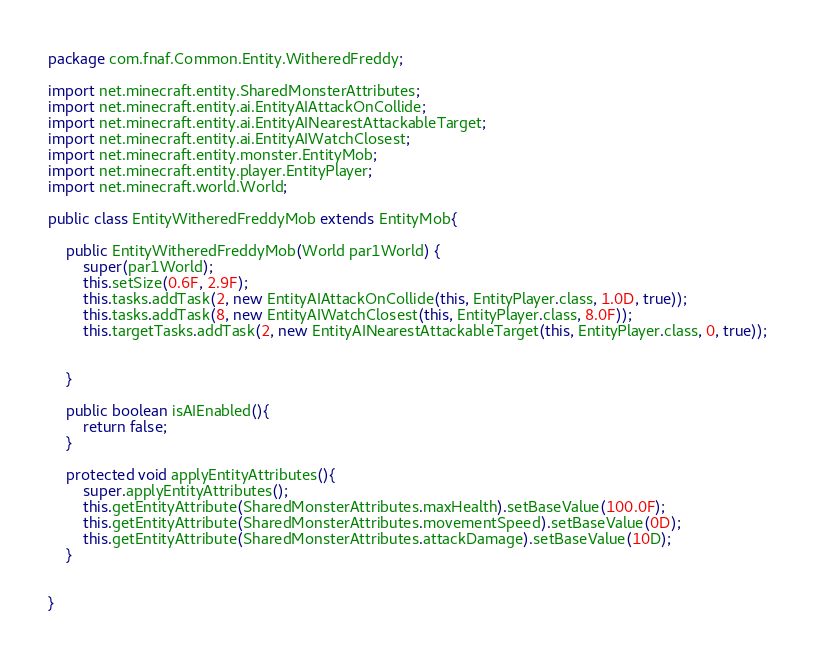Convert code to text. <code><loc_0><loc_0><loc_500><loc_500><_Java_>package com.fnaf.Common.Entity.WitheredFreddy;

import net.minecraft.entity.SharedMonsterAttributes;
import net.minecraft.entity.ai.EntityAIAttackOnCollide;
import net.minecraft.entity.ai.EntityAINearestAttackableTarget;
import net.minecraft.entity.ai.EntityAIWatchClosest;
import net.minecraft.entity.monster.EntityMob;
import net.minecraft.entity.player.EntityPlayer;
import net.minecraft.world.World;

public class EntityWitheredFreddyMob extends EntityMob{

	public EntityWitheredFreddyMob(World par1World) {
		super(par1World);
	    this.setSize(0.6F, 2.9F);
		this.tasks.addTask(2, new EntityAIAttackOnCollide(this, EntityPlayer.class, 1.0D, true));
        this.tasks.addTask(8, new EntityAIWatchClosest(this, EntityPlayer.class, 8.0F));
        this.targetTasks.addTask(2, new EntityAINearestAttackableTarget(this, EntityPlayer.class, 0, true));
		
		
	}
	
	public boolean isAIEnabled(){
		return false;
	}
	
	protected void applyEntityAttributes(){
		super.applyEntityAttributes();
		this.getEntityAttribute(SharedMonsterAttributes.maxHealth).setBaseValue(100.0F);
		this.getEntityAttribute(SharedMonsterAttributes.movementSpeed).setBaseValue(0D);
		this.getEntityAttribute(SharedMonsterAttributes.attackDamage).setBaseValue(10D);
	}


}</code> 